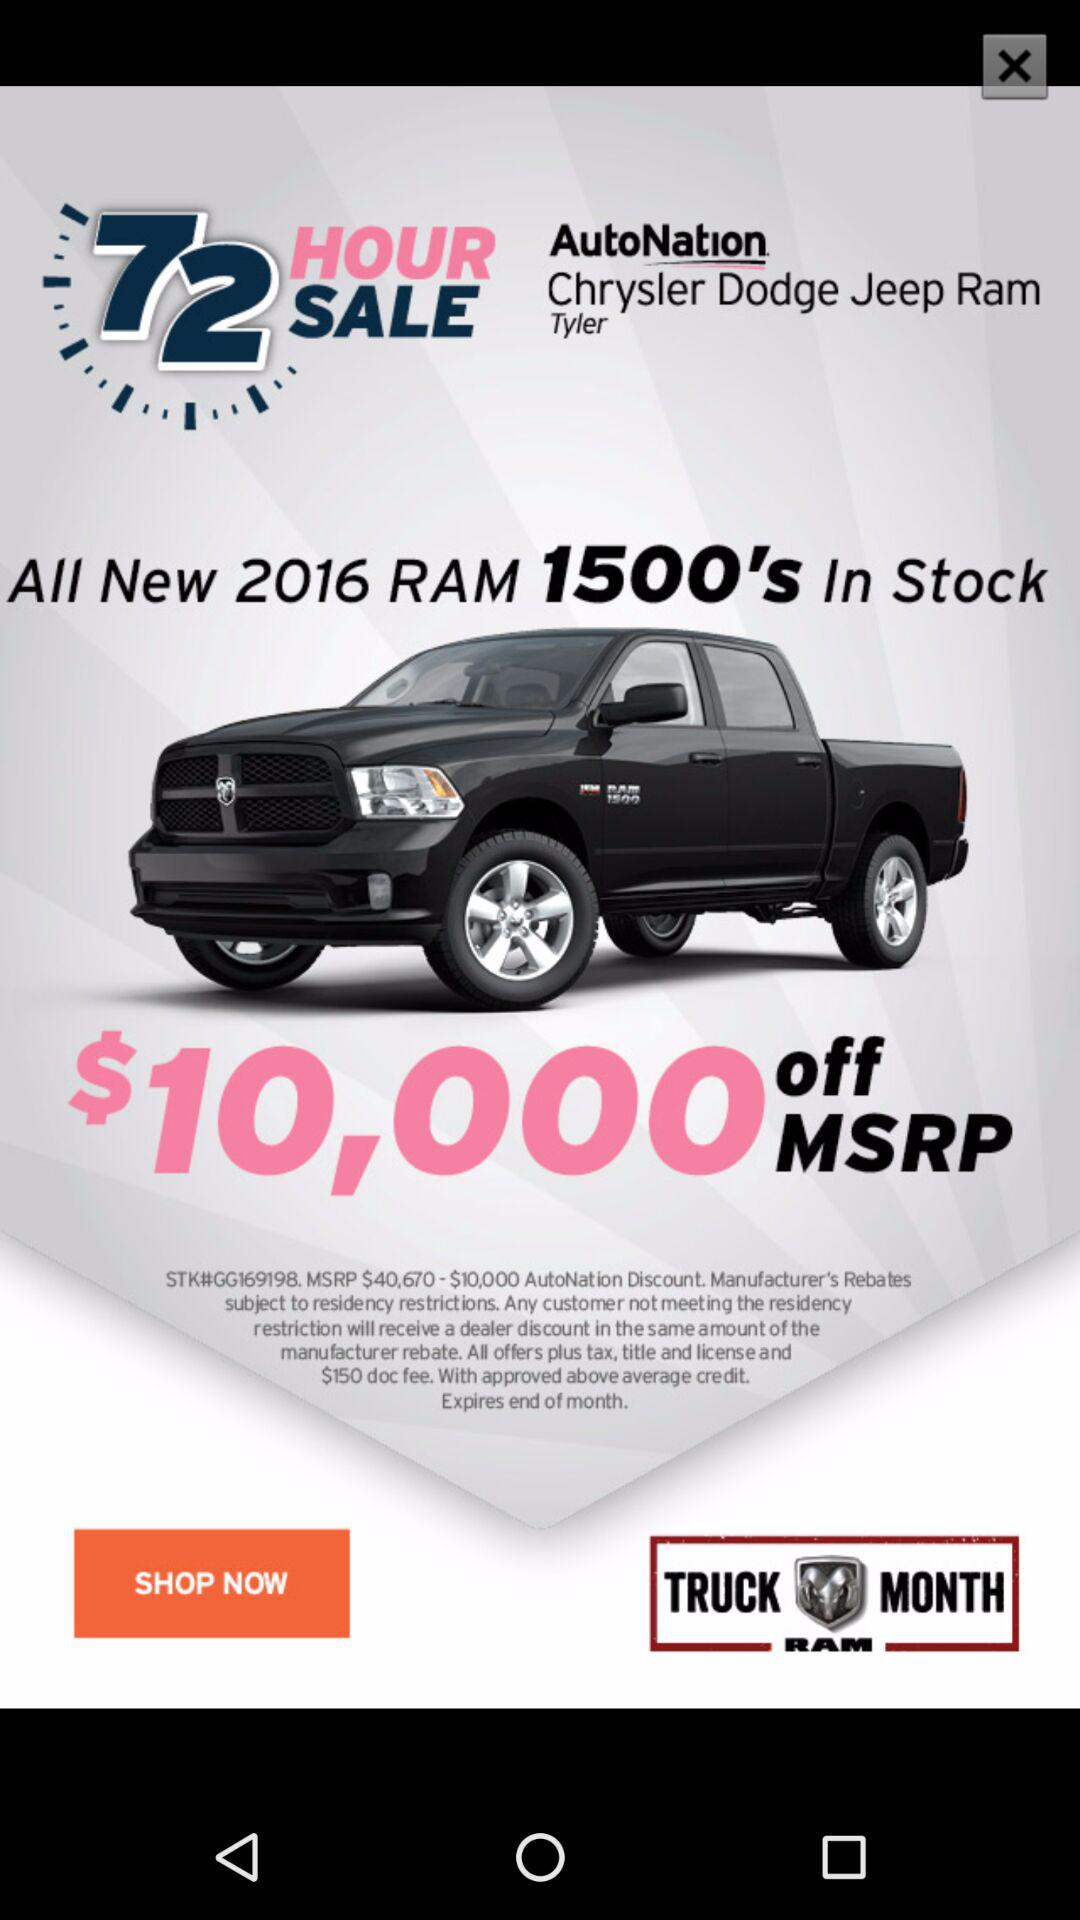How much is the manufacturer's rebate on the truck?
Answer the question using a single word or phrase. $10,000 